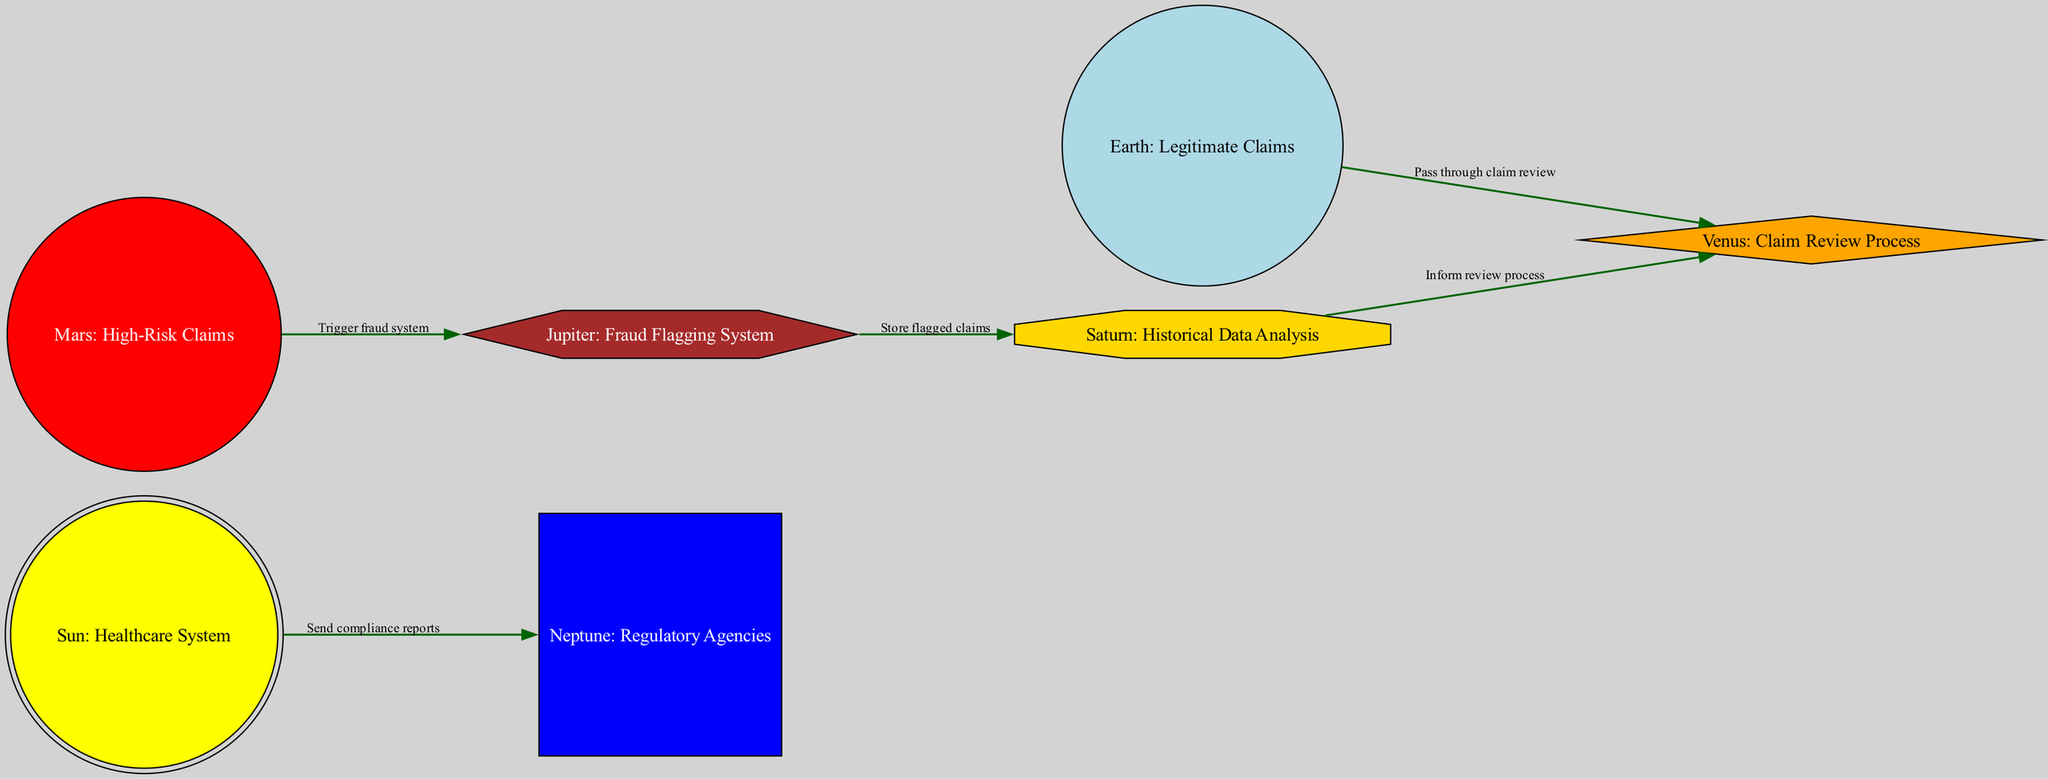What is the central entity in the diagram? The central entity is labeled as "Sun: Healthcare System". This represents the main focus of the diagram around which all other nodes (entities) revolve.
Answer: Sun: Healthcare System How many nodes are present in the diagram? By counting the distinct labeled entities in the diagram, we find there are a total of seven nodes that represent different aspects of healthcare claims and fraud detection.
Answer: 7 What color is the node representing High-Risk Claims? The node labeled "Mars: High-Risk Claims" is filled with a red color, which is used to signify its alert status regarding potentially fraudulent claims.
Answer: Red Which node does Legitimate Claims pass through? The diagram indicates that Legitimate Claims (Earth) pass through the Claim Review Process (Venus), representing that legitimate claims are reviewed for accuracy.
Answer: Claim Review Process What action occurs between High-Risk Claims and the Fraud Flagging System? The edge connecting "Mars: High-Risk Claims" to "Jupiter: Fraud Flagging System" is labeled "Trigger fraud system", indicating that high-risk claims trigger the fraud detection mechanisms.
Answer: Trigger fraud system Which node informs the Claim Review Process using historical data? The edge from "Saturn: Historical Data Analysis" to "Venus: Claim Review Process" indicates that historical data analysis directly informs the claim review process, suggesting that insights from past data improve current claim evaluations.
Answer: Historical Data Analysis What type of action does the Sun send to Regulatory Agencies? The diagram shows that the Sun (Healthcare System) sends "compliance reports" to the node representing Regulatory Agencies (Neptune). This action suggests a regulatory oversight on the healthcare activities.
Answer: Compliance reports How does the Fraud Flagging System relate to historical claims? The connection from the Fraud Flagging System (Jupiter) to Historical Data Analysis (Saturn) indicates that flagged claims are stored and maintained specifically for historical analysis, suggesting a continuous investigation process based on past behaviors.
Answer: Store flagged claims What is the role of Regulatory Agencies in this system? The node labeled "Neptune: Regulatory Agencies" signifies their role as external bodies that ensure compliance within the healthcare system as per the diagram. This means they provide oversight on the claims process and related activities.
Answer: External bodies ensuring compliance 